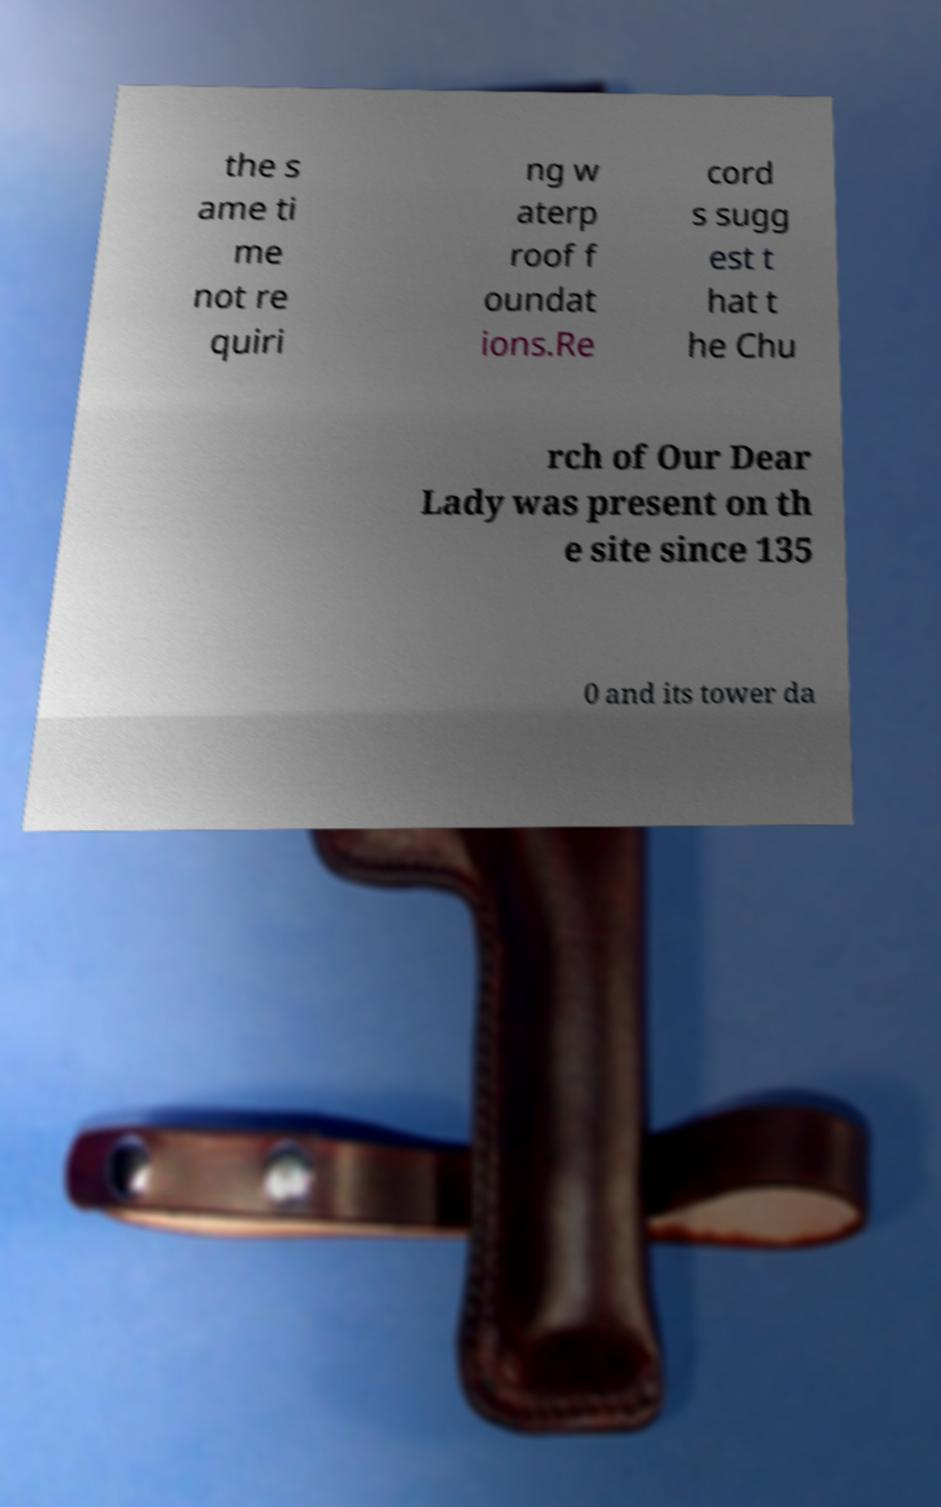Please identify and transcribe the text found in this image. the s ame ti me not re quiri ng w aterp roof f oundat ions.Re cord s sugg est t hat t he Chu rch of Our Dear Lady was present on th e site since 135 0 and its tower da 